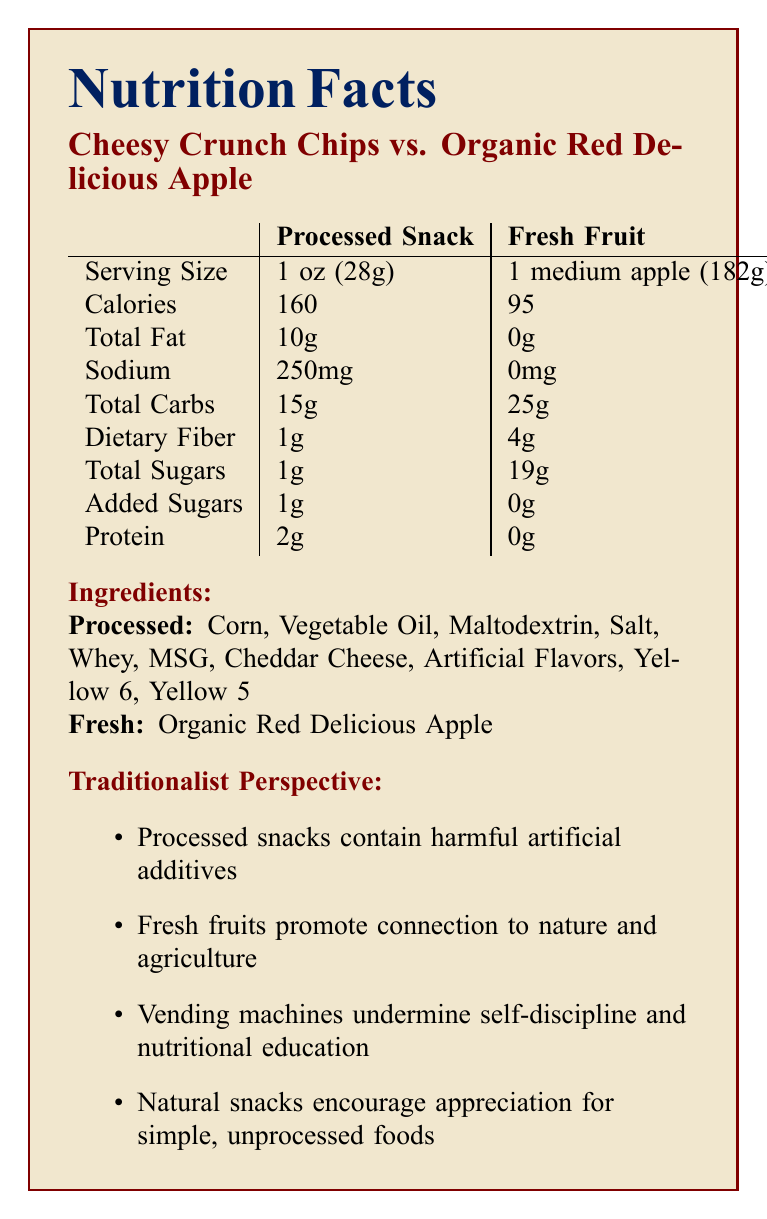what is the serving size of the Cheesy Crunch Chips? The serving size for the Cheesy Crunch Chips is listed as 1 oz (28g) in the document.
Answer: 1 oz (28g) what is the caloric difference between the Cheesy Crunch Chips and the Organic Red Delicious Apple? The Cheesy Crunch Chips have 160 calories, while the Organic Red Delicious Apple has 95 calories. The difference is 160 - 95 = 65 calories.
Answer: 65 calories how much sodium does the Organic Red Delicious Apple contain? The document lists the sodium content for the Organic Red Delicious Apple as 0 mg.
Answer: 0 mg which item contains added sugars? A. Cheesy Crunch Chips B. Organic Red Delicious Apple C. Both The document indicates that the Cheesy Crunch Chips contain 1g of added sugars, while the Organic Red Delicious Apple contains none.
Answer: A what health concerns are associated with the processed snacks according to the traditionalist perspective? The traditionalist perspective mentions that processed snacks contain harmful artificial additives, have high sodium content, and excessive sugar, which contribute to health issues like increased blood pressure, obesity, and diabetes.
Answer: Harmful artificial additives, high sodium content, excessive sugar which item promotes a connection to nature and agriculture according to the traditionalist perspective? Based on the traditionalist perspective, fresh fruits such as the Organic Red Delicious Apple promote a connection to nature and agriculture.
Answer: Organic Red Delicious Apple what is the total carbohydrate content in a serving of Organic Red Delicious Apple? The document indicates that the Organic Red Delicious Apple contains 25g of total carbohydrates per serving.
Answer: 25g which type of snacks are said to undermine self-discipline according to the traditionalist perspective? A. Fresh Fruits B. Processed Snacks C. Both D. Neither The traditionalist perspective specifically states that vending machines with processed snacks undermine self-discipline.
Answer: B does the Cheesy Crunch Chips contain artificial flavors? The document lists artificial flavors among the ingredients of the Cheesy Crunch Chips.
Answer: Yes is there more dietary fiber in the Cheesy Crunch Chips or the Organic Red Delicious Apple? The document indicates that the Cheesy Crunch Chips have 1g of dietary fiber, while the Organic Red Delicious Apple contains 4g of dietary fiber.
Answer: Organic Red Delicious Apple describe the main idea of the document. The document includes a comparison of the nutritional content, ingredients, and the traditionalist views on processed snacks vs. fresh fruits for student vending machines. It emphasizes the health benefits of fresh fruits and concerns about processed snacks, aligning with traditional values and economic benefits.
Answer: The document contrasts the nutritional information, ingredients, and traditionalist perspectives on processed snacks (Cheesy Crunch Chips) versus fresh fruit (Organic Red Delicious Apple) for student vending machines. It highlights the health concerns, educational impact, traditional values, and economic considerations favoring fresh fruits over processed snacks. what is the vitamin C content in the Cheesy Crunch Chips? The document does not list information regarding vitamin C content for the Cheesy Crunch Chips.
Answer: Not provided 